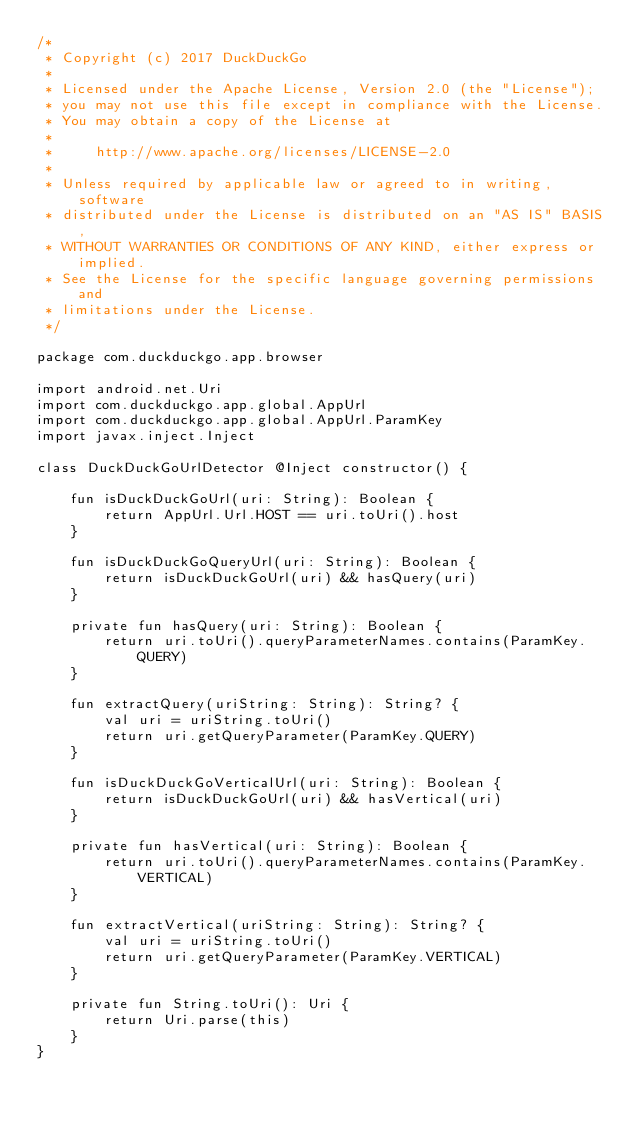Convert code to text. <code><loc_0><loc_0><loc_500><loc_500><_Kotlin_>/*
 * Copyright (c) 2017 DuckDuckGo
 *
 * Licensed under the Apache License, Version 2.0 (the "License");
 * you may not use this file except in compliance with the License.
 * You may obtain a copy of the License at
 *
 *     http://www.apache.org/licenses/LICENSE-2.0
 *
 * Unless required by applicable law or agreed to in writing, software
 * distributed under the License is distributed on an "AS IS" BASIS,
 * WITHOUT WARRANTIES OR CONDITIONS OF ANY KIND, either express or implied.
 * See the License for the specific language governing permissions and
 * limitations under the License.
 */

package com.duckduckgo.app.browser

import android.net.Uri
import com.duckduckgo.app.global.AppUrl
import com.duckduckgo.app.global.AppUrl.ParamKey
import javax.inject.Inject

class DuckDuckGoUrlDetector @Inject constructor() {

    fun isDuckDuckGoUrl(uri: String): Boolean {
        return AppUrl.Url.HOST == uri.toUri().host
    }

    fun isDuckDuckGoQueryUrl(uri: String): Boolean {
        return isDuckDuckGoUrl(uri) && hasQuery(uri)
    }

    private fun hasQuery(uri: String): Boolean {
        return uri.toUri().queryParameterNames.contains(ParamKey.QUERY)
    }

    fun extractQuery(uriString: String): String? {
        val uri = uriString.toUri()
        return uri.getQueryParameter(ParamKey.QUERY)
    }

    fun isDuckDuckGoVerticalUrl(uri: String): Boolean {
        return isDuckDuckGoUrl(uri) && hasVertical(uri)
    }

    private fun hasVertical(uri: String): Boolean {
        return uri.toUri().queryParameterNames.contains(ParamKey.VERTICAL)
    }

    fun extractVertical(uriString: String): String? {
        val uri = uriString.toUri()
        return uri.getQueryParameter(ParamKey.VERTICAL)
    }

    private fun String.toUri(): Uri {
        return Uri.parse(this)
    }
}
</code> 